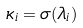<formula> <loc_0><loc_0><loc_500><loc_500>\kappa _ { i } = \sigma ( \lambda _ { i } )</formula> 